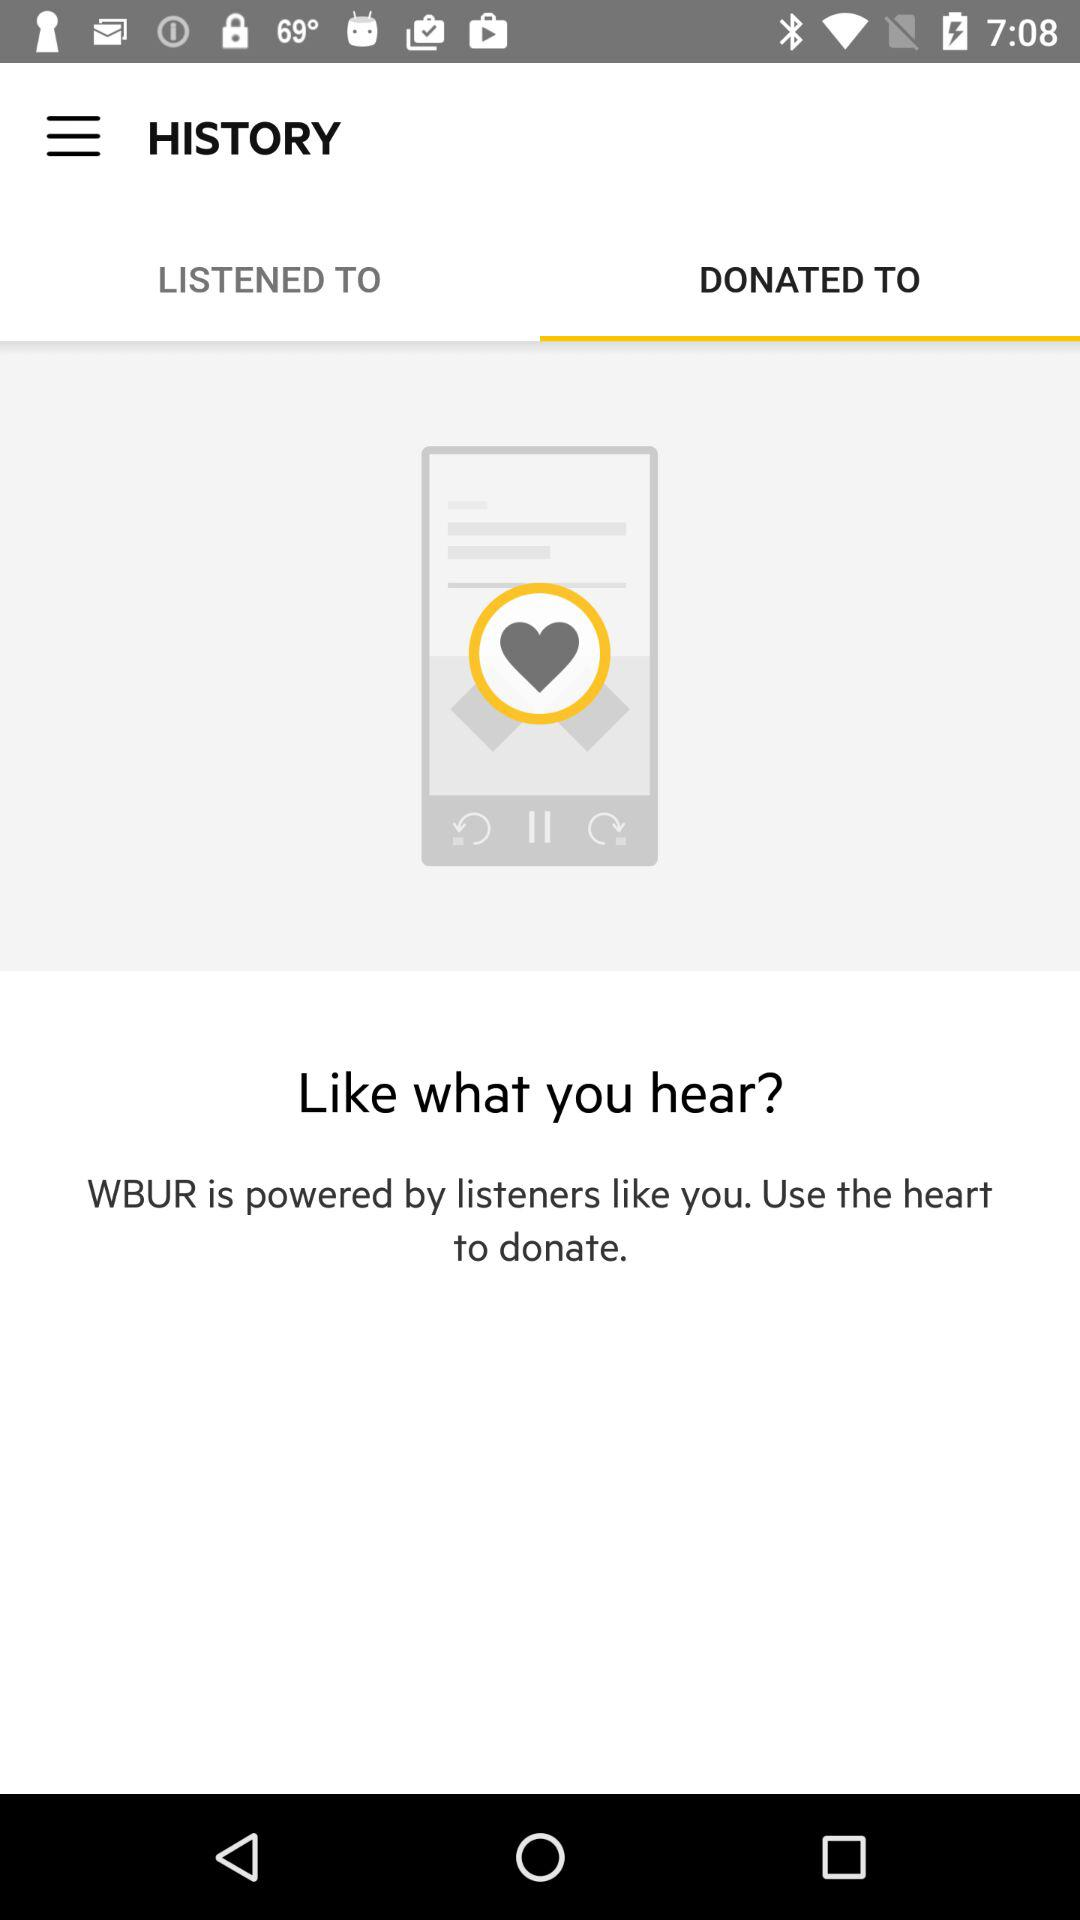Which tab is selected? The selected tab is "DONATED TO". 